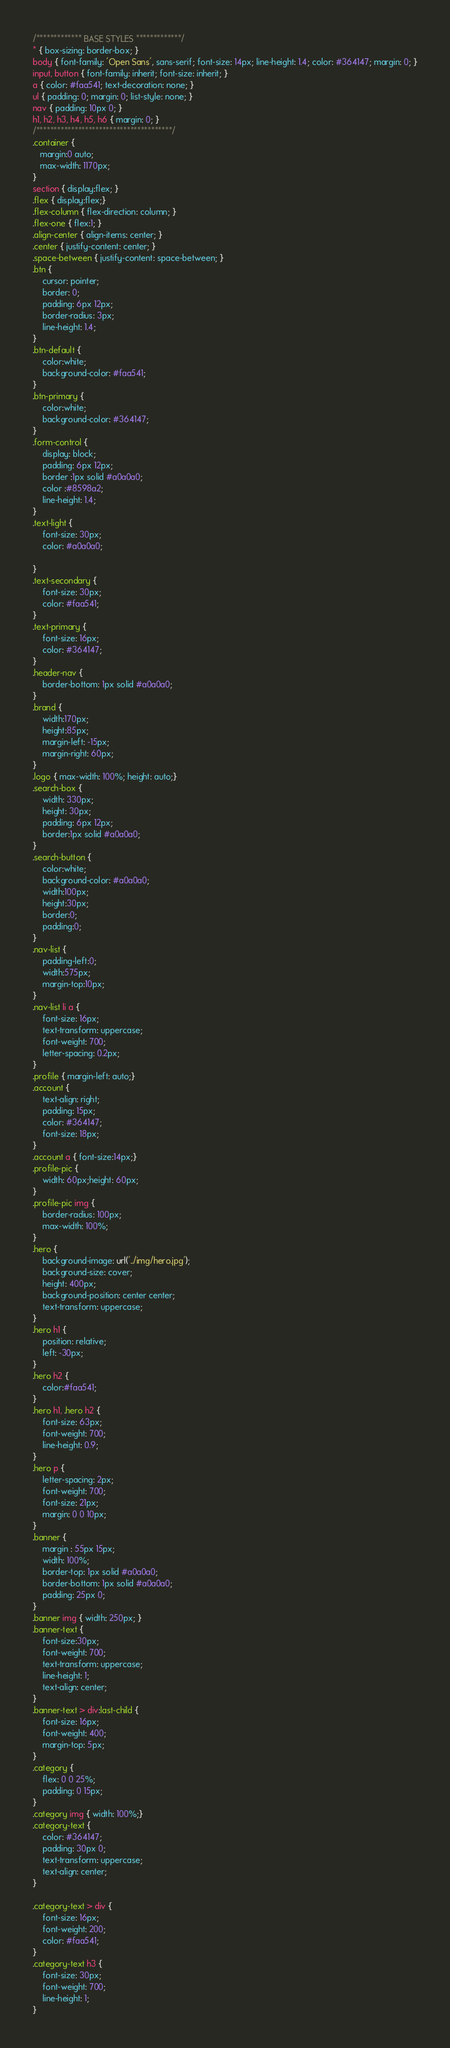Convert code to text. <code><loc_0><loc_0><loc_500><loc_500><_CSS_>/************* BASE STYLES *************/
* { box-sizing: border-box; }
body { font-family: 'Open Sans', sans-serif; font-size: 14px; line-height: 1.4; color: #364147; margin: 0; }
input, button { font-family: inherit; font-size: inherit; }
a { color: #faa541; text-decoration: none; }
ul { padding: 0; margin: 0; list-style: none; }
nav { padding: 10px 0; }
h1, h2, h3, h4, h5, h6 { margin: 0; }
/***************************************/
.container {  
   margin:0 auto;
   max-width: 1170px;
}
section { display:flex; }
.flex { display:flex;}
.flex-column { flex-direction: column; }
.flex-one { flex:1; }
.align-center { align-items: center; }
.center { justify-content: center; }
.space-between { justify-content: space-between; }
.btn {
    cursor: pointer;
    border: 0;
    padding: 6px 12px;
    border-radius: 3px;
    line-height: 1.4;
}
.btn-default {
    color:white;
    background-color: #faa541;
}
.btn-primary {
    color:white;
    background-color: #364147;
}
.form-control {
    display: block;
    padding: 6px 12px;
    border :1px solid #a0a0a0;
    color :#8598a2;
    line-height: 1.4;
}
.text-light { 
    font-size: 30px;
    color: #a0a0a0;

}
.text-secondary { 
    font-size: 30px;
    color: #faa541;
}
.text-primary { 
    font-size: 16px;
    color: #364147;
}
.header-nav {
    border-bottom: 1px solid #a0a0a0;
}
.brand {
    width:170px;
    height:85px;
    margin-left: -15px;
    margin-right: 60px;
}
.logo { max-width: 100%; height: auto;}
.search-box {
    width: 330px;
    height: 30px;
    padding: 6px 12px;
    border:1px solid #a0a0a0;
}
.search-button {
    color:white;
    background-color: #a0a0a0;
    width:100px;
    height:30px;
    border:0;
    padding:0;
}
.nav-list {
    padding-left:0;
    width:575px;
    margin-top:10px;
}
.nav-list li a {
    font-size: 16px;
    text-transform: uppercase;
    font-weight: 700;
    letter-spacing: 0.2px;
}
.profile { margin-left: auto;}
.account {
    text-align: right;
    padding: 15px;
    color: #364147;
    font-size: 18px;
}
.account a { font-size:14px;}
.profile-pic {
    width: 60px;height: 60px;
}
.profile-pic img {
    border-radius: 100px;
    max-width: 100%;
}
.hero {
    background-image: url('../img/hero.jpg');
    background-size: cover;
    height: 400px;
    background-position: center center;
    text-transform: uppercase;
}
.hero h1 {
    position: relative;
    left: -30px;
}
.hero h2 {
    color:#faa541;
}
.hero h1, .hero h2 {
    font-size: 63px;
    font-weight: 700;
    line-height: 0.9;
}
.hero p {
    letter-spacing: 2px;
    font-weight: 700;
    font-size: 21px;
    margin: 0 0 10px;
}
.banner {
    margin : 55px 15px;
    width: 100%;
    border-top: 1px solid #a0a0a0;
    border-bottom: 1px solid #a0a0a0;
    padding: 25px 0;
}
.banner img { width: 250px; }
.banner-text {
    font-size:30px;
    font-weight: 700;
    text-transform: uppercase;
    line-height: 1;
    text-align: center;
}
.banner-text > div:last-child {
    font-size: 16px;
    font-weight: 400;
    margin-top: 5px;
}
.category {
    flex: 0 0 25%;
    padding: 0 15px;
}
.category img { width: 100%;}
.category-text { 
    color: #364147;
    padding: 30px 0;
    text-transform: uppercase;
    text-align: center;
}

.category-text > div {
    font-size: 16px;
    font-weight: 200;
    color: #faa541;
}
.category-text h3 {
    font-size: 30px;
    font-weight: 700;
    line-height: 1;
}</code> 